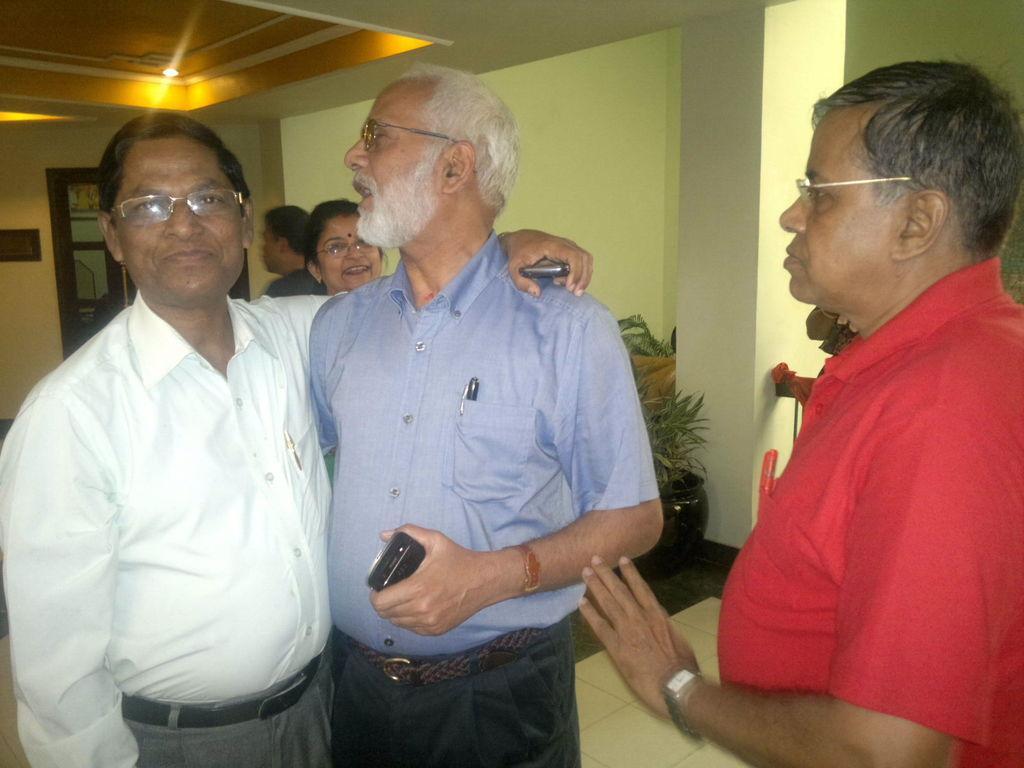Please provide a concise description of this image. In the foreground of this image, there are three men standing where two men are holding mobile phones. In the background, there are two people, a plant, wall, door and a light to the ceiling. 